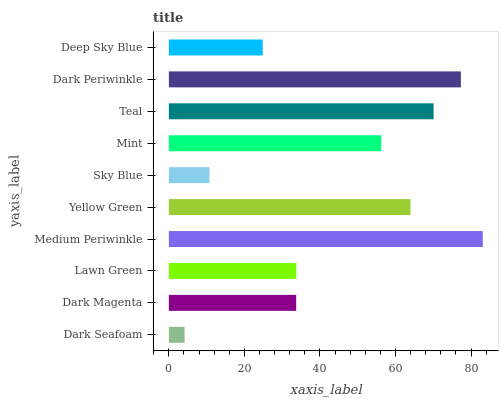Is Dark Seafoam the minimum?
Answer yes or no. Yes. Is Medium Periwinkle the maximum?
Answer yes or no. Yes. Is Dark Magenta the minimum?
Answer yes or no. No. Is Dark Magenta the maximum?
Answer yes or no. No. Is Dark Magenta greater than Dark Seafoam?
Answer yes or no. Yes. Is Dark Seafoam less than Dark Magenta?
Answer yes or no. Yes. Is Dark Seafoam greater than Dark Magenta?
Answer yes or no. No. Is Dark Magenta less than Dark Seafoam?
Answer yes or no. No. Is Mint the high median?
Answer yes or no. Yes. Is Lawn Green the low median?
Answer yes or no. Yes. Is Teal the high median?
Answer yes or no. No. Is Mint the low median?
Answer yes or no. No. 